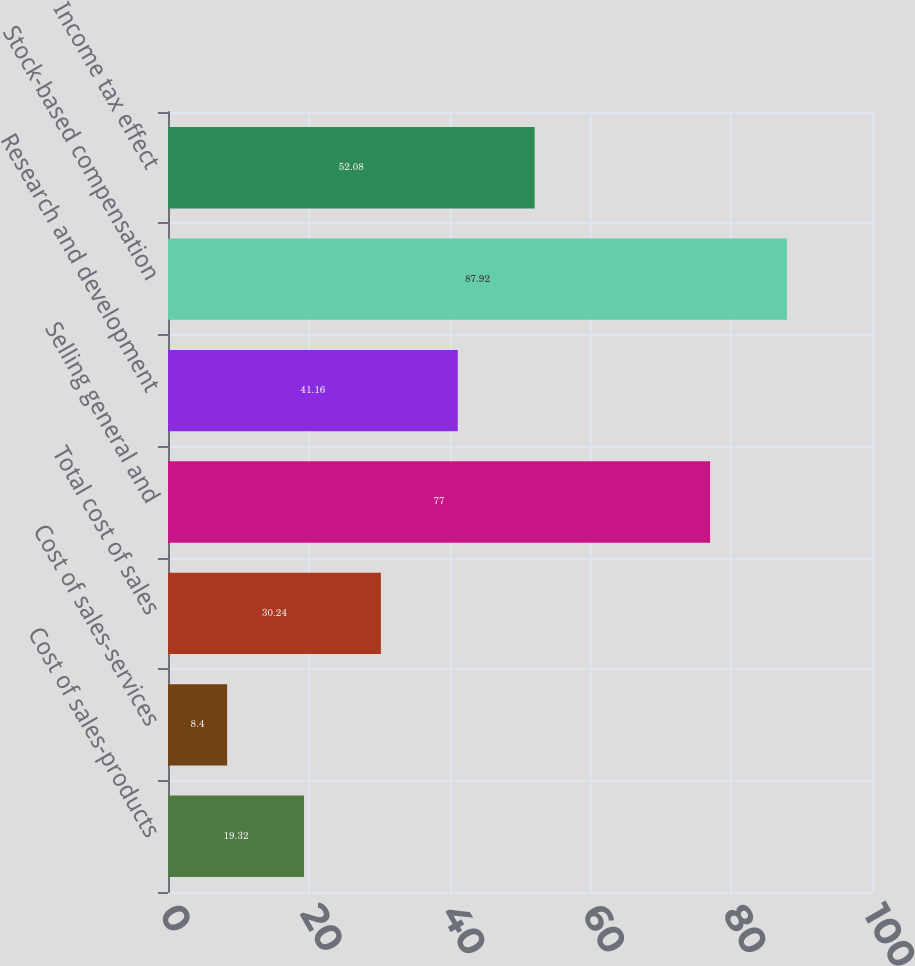<chart> <loc_0><loc_0><loc_500><loc_500><bar_chart><fcel>Cost of sales-products<fcel>Cost of sales-services<fcel>Total cost of sales<fcel>Selling general and<fcel>Research and development<fcel>Stock-based compensation<fcel>Income tax effect<nl><fcel>19.32<fcel>8.4<fcel>30.24<fcel>77<fcel>41.16<fcel>87.92<fcel>52.08<nl></chart> 